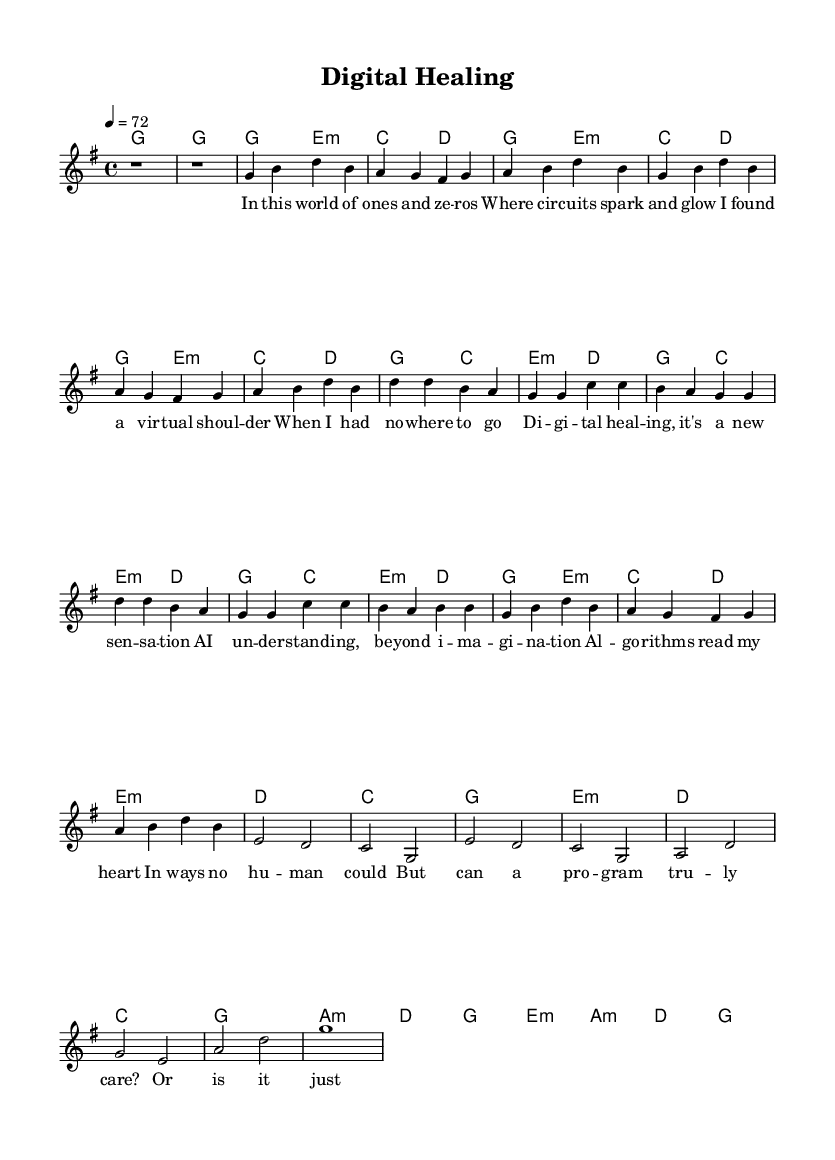What is the key signature of this music? The key signature indicates G major, which has one sharp (F#). The presence of an F# in the melody and harmony confirms this.
Answer: G major What is the time signature? The time signature is found at the beginning of the score, which shows 4/4, indicating four beats per measure. Each beat can be a quarter note.
Answer: 4/4 What is the tempo marking for this piece? The tempo is notated at the beginning as "4 = 72", meaning there are 72 quarter note beats per minute. This sets a moderate tempo for the piece.
Answer: 72 How many verses are present in this score? The score has two verses: the first verse is fully written, while the second verse is abbreviated. This can be identified by the labeled sections in the lyrics.
Answer: 2 What is the primary theme of the chorus? The chorus expresses the theme of digital healing and the connectedness provided by AI, as reflected in the lyrics. The repetition of "Digital healing" emphasizes this idea.
Answer: Digital healing How does the bridge differ from the verses in lyrical content? The bridge questions the emotional authenticity of virtual therapy, contrasting the supportive nature of the verses that focus on connection and healing through technology. This change in tone adds depth and complexity.
Answer: Emotional authenticity What chord does the song start with? The song begins with a G major chord, which is indicated by the chord names in the score. This sets the tonal foundation for the following sections.
Answer: G major 